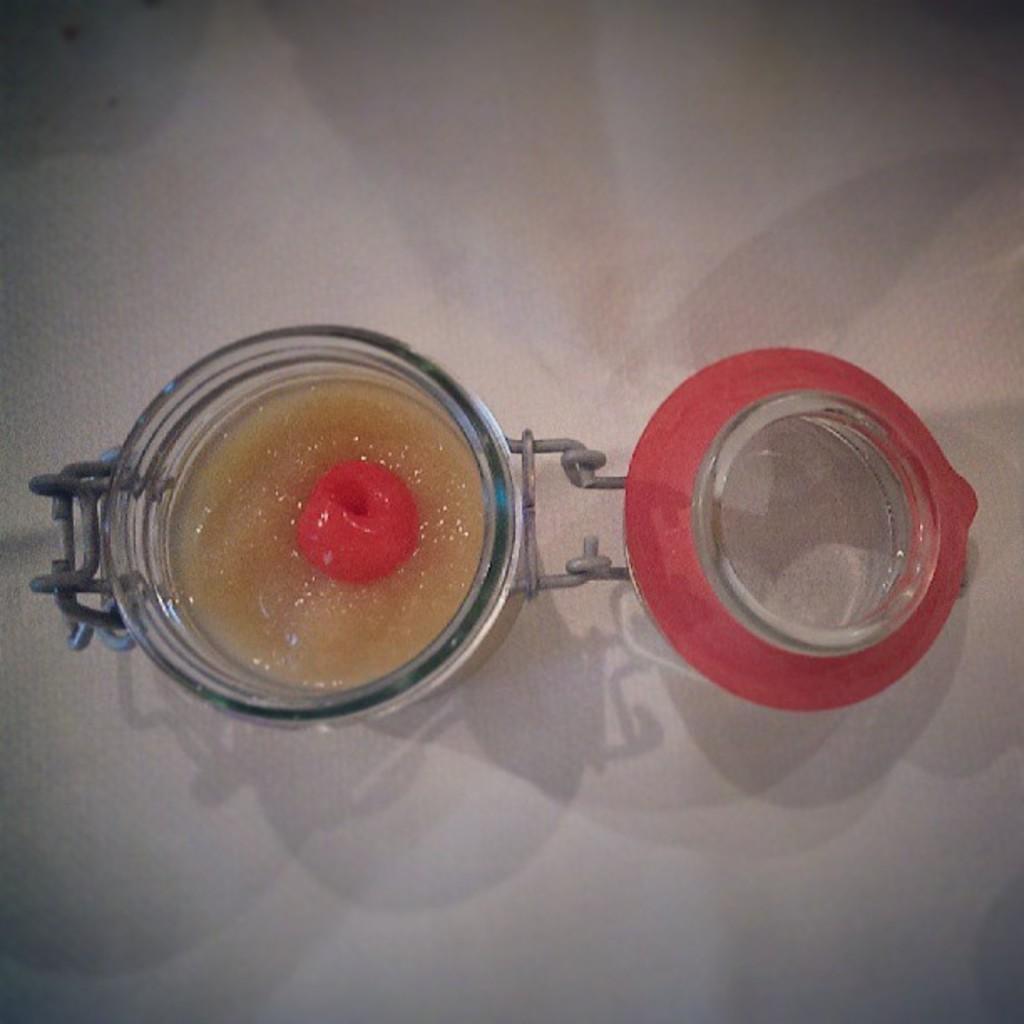Could you give a brief overview of what you see in this image? In this picture which is kept on the table. In that jag we can see some food item. 